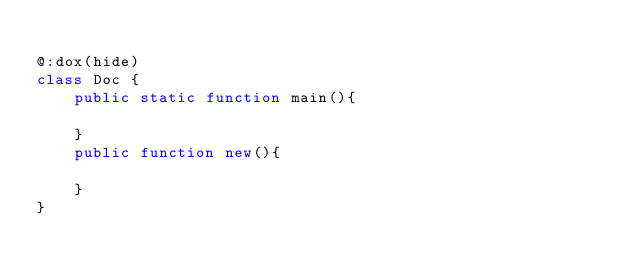Convert code to text. <code><loc_0><loc_0><loc_500><loc_500><_Haxe_>
@:dox(hide)
class Doc {
    public static function main(){
        
    }
    public function new(){
        
    }
}</code> 